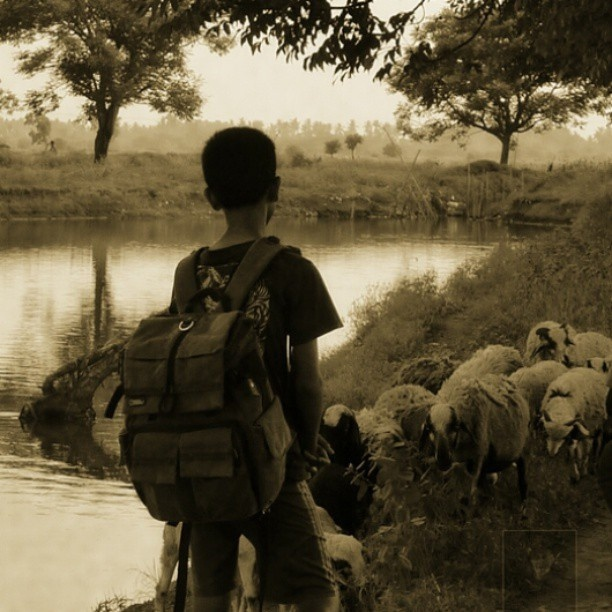Describe the objects in this image and their specific colors. I can see people in olive and black tones, backpack in olive, black, and tan tones, sheep in olive and black tones, sheep in olive, black, and gray tones, and sheep in olive and black tones in this image. 